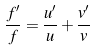<formula> <loc_0><loc_0><loc_500><loc_500>\frac { f ^ { \prime } } { f } = \frac { u ^ { \prime } } { u } + \frac { v ^ { \prime } } { v }</formula> 